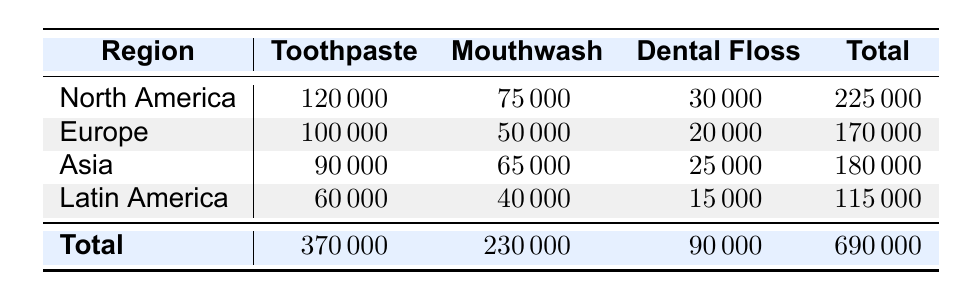What is the total sales for Toothpaste in North America? The table shows that the sales for Toothpaste in North America are listed as 120000. Thus, the total sales for Toothpaste in this region is directly taken from the table.
Answer: 120000 Which region has the highest sales in Mouthwash? By comparing the values in the Mouthwash column for all regions, North America has 75000, Europe has 50000, Asia has 65000, and Latin America has 40000. The highest value is 75000 for North America.
Answer: North America What is the combined sales of Dental Floss in Europe and Asia? In the table, the sales for Dental Floss in Europe is 20000, and in Asia, it's 25000. Adding these together gives 20000 + 25000 = 45000.
Answer: 45000 Did Latin America achieve higher sales in Toothpaste than in Dental Floss? The sales for Toothpaste in Latin America is 60000, while the sales for Dental Floss is 15000. Since 60000 is greater than 15000, the answer is yes.
Answer: Yes What is the total sales across all regions for all product categories? The total sales for all regions and product categories are provided in the last column of the table. The sum is 225000 (North America) + 170000 (Europe) + 180000 (Asia) + 115000 (Latin America) = 690000, confirming the total sales value.
Answer: 690000 Which product category has the lowest total sales across all regions? By reviewing the total sales for each product category, we see Toothpaste totals 370000, Mouthwash totals 230000, and Dental Floss totals 90000. The lowest value is 90000 for Dental Floss.
Answer: Dental Floss How much greater is the total sales for Toothpaste compared to Dental Floss? The total sales for Toothpaste is 370000 and for Dental Floss is 90000. The difference is calculated as 370000 - 90000 = 280000.
Answer: 280000 Is the sales performance for Mouthwash in Asia greater than in Latin America? The sales for Mouthwash in Asia is 65000, while in Latin America it is 40000. Since 65000 is greater than 40000, the answer is yes.
Answer: Yes What is the average sales of Dental Floss across all regions? The sales for Dental Floss are 30000 (North America), 20000 (Europe), 25000 (Asia), and 15000 (Latin America). The total is 30000 + 20000 + 25000 + 15000 = 90000, and there are 4 regions, so the average is 90000 / 4 = 22500.
Answer: 22500 